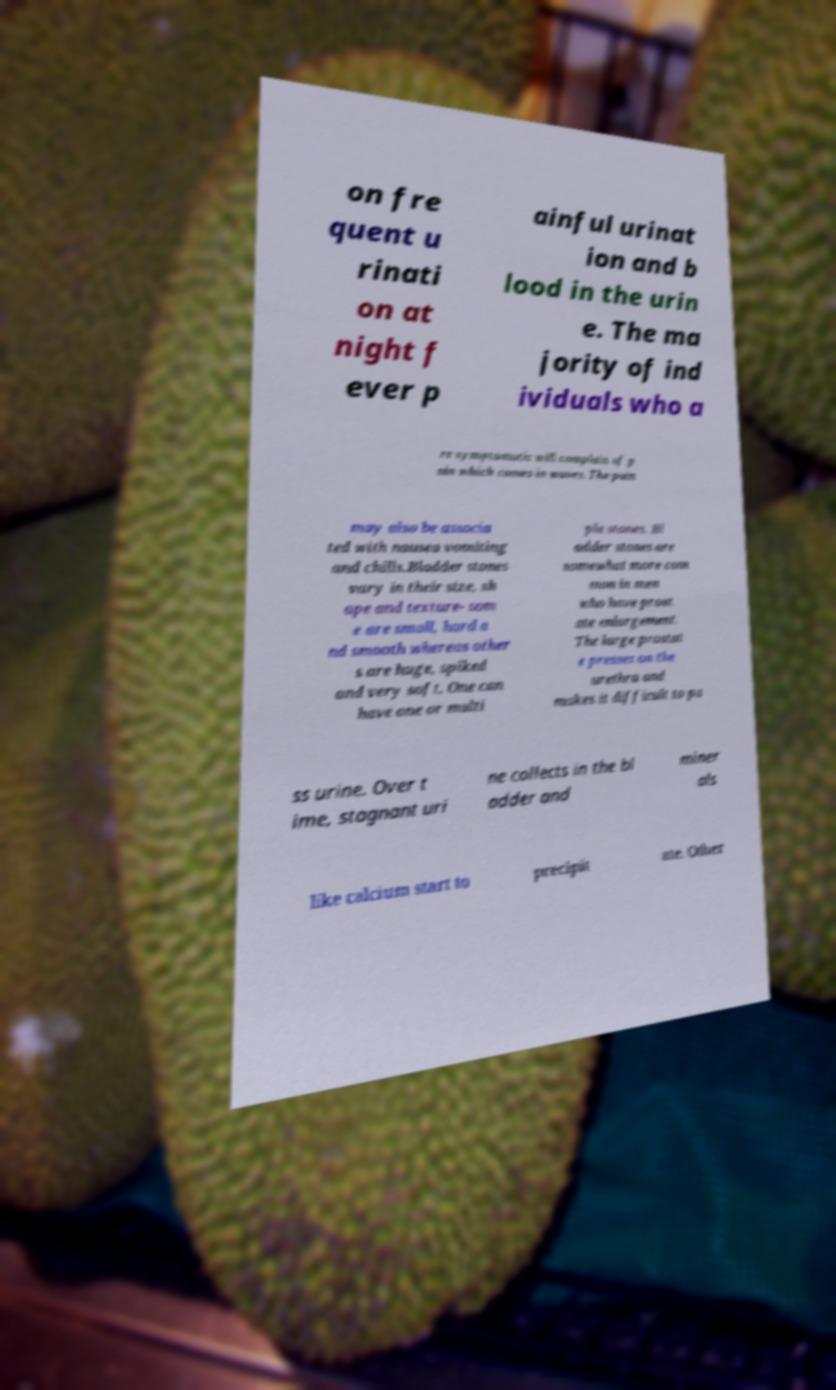I need the written content from this picture converted into text. Can you do that? on fre quent u rinati on at night f ever p ainful urinat ion and b lood in the urin e. The ma jority of ind ividuals who a re symptomatic will complain of p ain which comes in waves. The pain may also be associa ted with nausea vomiting and chills.Bladder stones vary in their size, sh ape and texture- som e are small, hard a nd smooth whereas other s are huge, spiked and very soft. One can have one or multi ple stones. Bl adder stones are somewhat more com mon in men who have prost ate enlargement. The large prostat e presses on the urethra and makes it difficult to pa ss urine. Over t ime, stagnant uri ne collects in the bl adder and miner als like calcium start to precipit ate. Other 